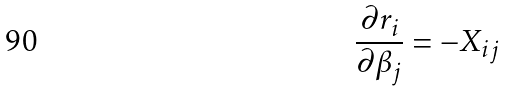<formula> <loc_0><loc_0><loc_500><loc_500>\frac { \partial r _ { i } } { \partial \beta _ { j } } = - X _ { i j }</formula> 